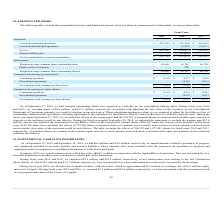From Macom Technology's financial document, What were the respective gains in 2019 and 2018? The document shows two values: $0.8 million and $27.6 million. From the document: "and 2018, we recorded gains of $0.8 million and $27.6 million, respectively, associated with adjusting the fair value of the warrants, in the Co and 2..." Also, What is the adjustment made when calculating earnings per share? the dilutive effect of outstanding common stock equivalents, including adjustment to the numerator for the dilutive effect of contracts that must be settled in common stock.. The document states: "g earnings per share we are required to adjust for the dilutive effect of outstanding common stock equivalents, including adjustment to the numerator ..." Also, What was the Loss from continuing operations in 2019? According to the financial document, $(383,798) (in thousands). The relevant text states: "Loss from continuing operations $ (383,798) $ (133,762) $ (150,416)..." Additionally, In which year was Loss from discontinued operations 0? According to the financial document, 2019. The relevant text states: "2019 2018 2017..." Also, can you calculate: What was the average Net loss for 2017 to 2019? To answer this question, I need to perform calculations using the financial data. The calculation is: (383,798 + 139,977 + 169,493) / 3, which equals 231089.33 (in thousands). This is based on the information: "Net loss (383,798) (139,977) (169,493) Net loss (383,798) (139,977) (169,493) Net loss (383,798) (139,977) (169,493)..." The key data points involved are: 139,977, 169,493, 383,798. Also, can you calculate: What is the change in the Weighted average common shares outstanding-basic from 2018 to 2019? Based on the calculation: 65,686 - 64,741, the result is 945 (in thousands). This is based on the information: "Weighted average common shares outstanding-basic 65,686 64,741 60,704 ed average common shares outstanding-basic 65,686 64,741 60,704..." The key data points involved are: 64,741, 65,686. 